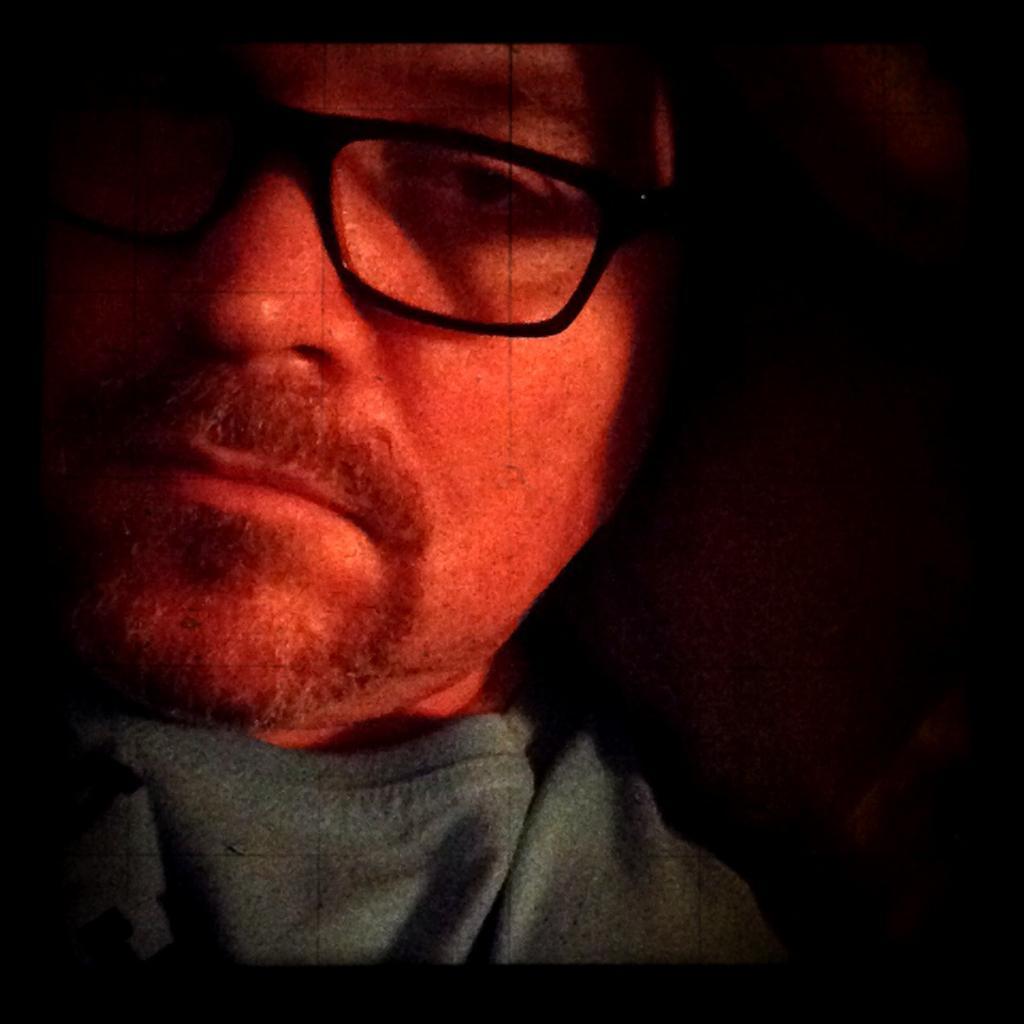Can you describe this image briefly? In this picture we can see a person wore a spectacle and in the background it is dark. 